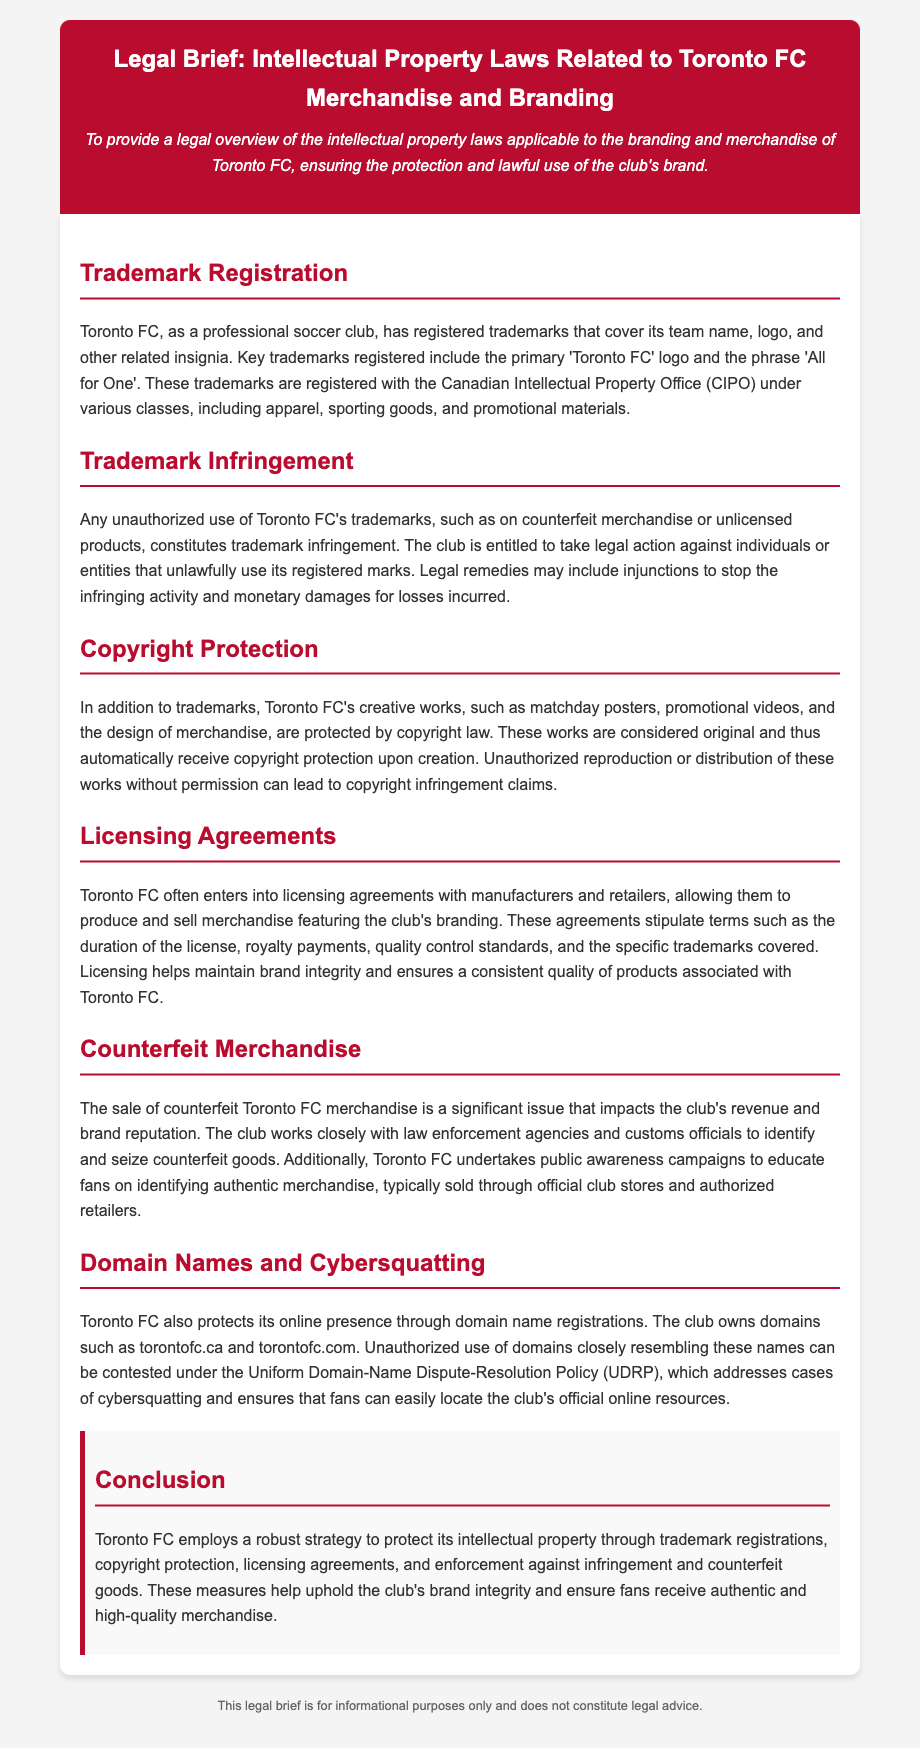What are the registered trademarks of Toronto FC? The document states that the key trademarks registered include the primary 'Toronto FC' logo and the phrase 'All for One'.
Answer: 'Toronto FC' logo, 'All for One' What legal action can Toronto FC take against trademark infringement? The document mentions that Toronto FC is entitled to take legal action against individuals or entities that unlawfully use its registered marks, which may include injunctions and monetary damages.
Answer: Legal action, injunctions, monetary damages What type of creative works does Toronto FC have that are protected by copyright? The document lists matchday posters, promotional videos, and the design of merchandise as creative works protected by copyright law.
Answer: Matchday posters, promotional videos, design of merchandise What do licensing agreements with Toronto FC stipulate? The document explains that these agreements stipulate terms such as duration, royalty payments, quality control standards, and trademarks covered.
Answer: Duration, royalty payments, quality control standards, trademarks covered What is the main purpose of Toronto FC's public awareness campaigns? The document states that these campaigns educate fans on identifying authentic merchandise.
Answer: Educate fans on identifying authentic merchandise What is the role of the Uniform Domain-Name Dispute-Resolution Policy? The document states that this policy addresses cases of cybersquatting and ensures fans can locate the club's official online resources.
Answer: Address cases of cybersquatting What is a significant issue impacting Toronto FC's revenue and brand reputation? The document highlights that the sale of counterfeit Toronto FC merchandise significantly impacts the club's revenue and brand reputation.
Answer: Sale of counterfeit merchandise What does Toronto FC own to protect its online presence? The document mentions that Toronto FC owns domains such as torontofc.ca and torontofc.com to protect its online presence.
Answer: torontofc.ca, torontofc.com 